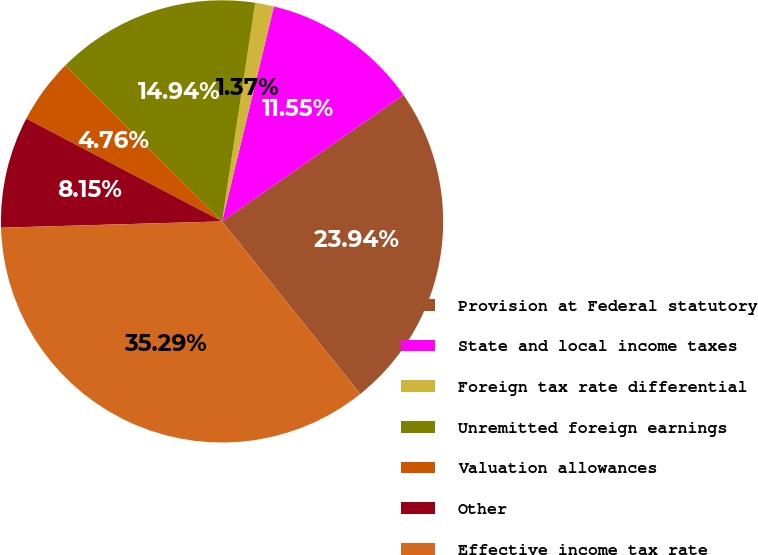Convert chart. <chart><loc_0><loc_0><loc_500><loc_500><pie_chart><fcel>Provision at Federal statutory<fcel>State and local income taxes<fcel>Foreign tax rate differential<fcel>Unremitted foreign earnings<fcel>Valuation allowances<fcel>Other<fcel>Effective income tax rate<nl><fcel>23.94%<fcel>11.55%<fcel>1.37%<fcel>14.94%<fcel>4.76%<fcel>8.15%<fcel>35.29%<nl></chart> 